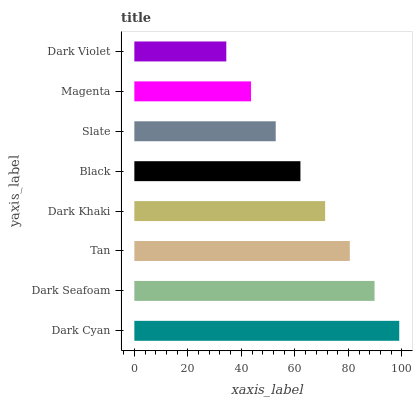Is Dark Violet the minimum?
Answer yes or no. Yes. Is Dark Cyan the maximum?
Answer yes or no. Yes. Is Dark Seafoam the minimum?
Answer yes or no. No. Is Dark Seafoam the maximum?
Answer yes or no. No. Is Dark Cyan greater than Dark Seafoam?
Answer yes or no. Yes. Is Dark Seafoam less than Dark Cyan?
Answer yes or no. Yes. Is Dark Seafoam greater than Dark Cyan?
Answer yes or no. No. Is Dark Cyan less than Dark Seafoam?
Answer yes or no. No. Is Dark Khaki the high median?
Answer yes or no. Yes. Is Black the low median?
Answer yes or no. Yes. Is Magenta the high median?
Answer yes or no. No. Is Tan the low median?
Answer yes or no. No. 